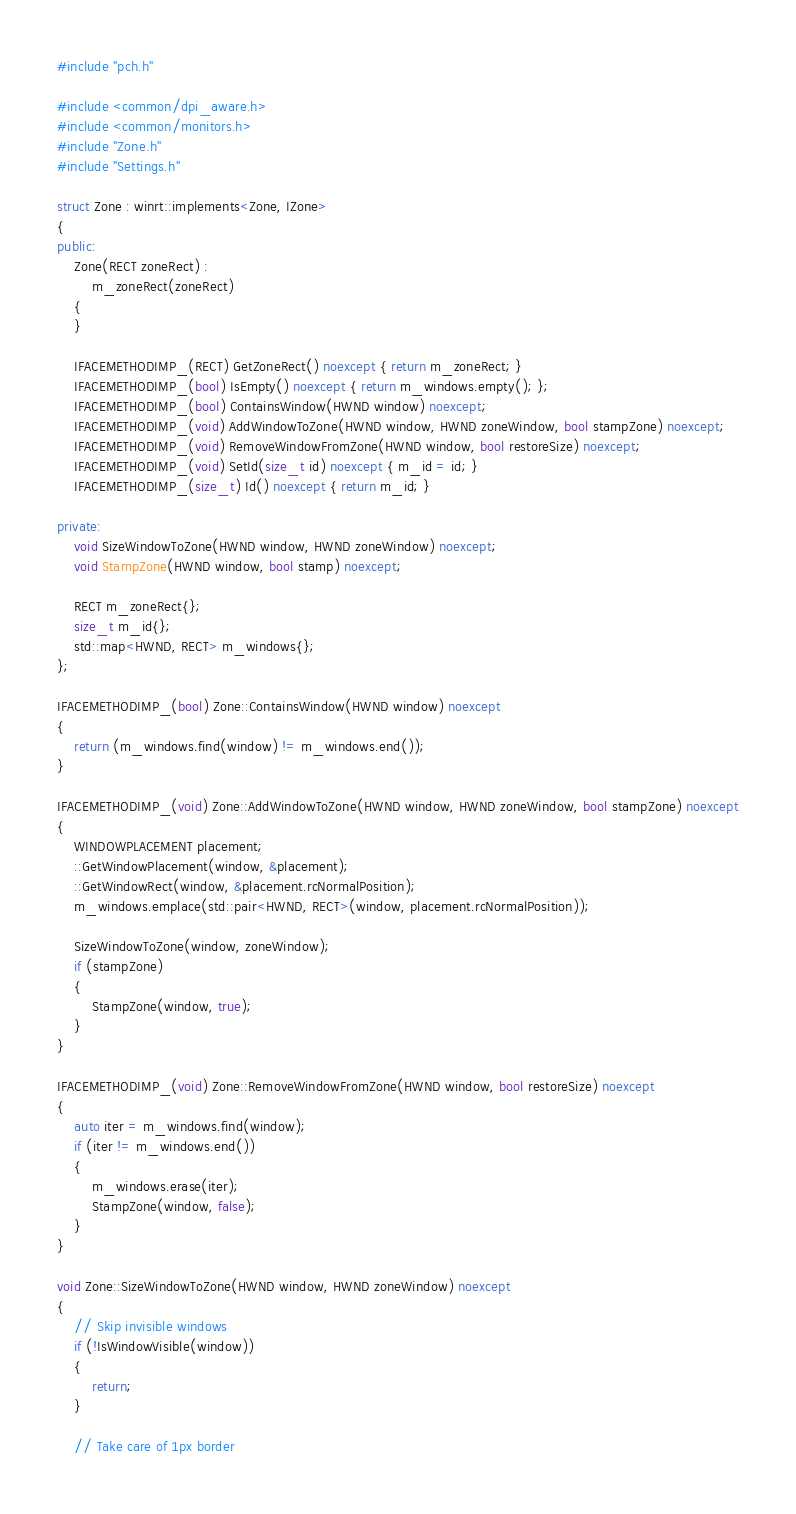<code> <loc_0><loc_0><loc_500><loc_500><_C++_>#include "pch.h"

#include <common/dpi_aware.h>
#include <common/monitors.h>
#include "Zone.h"
#include "Settings.h"

struct Zone : winrt::implements<Zone, IZone>
{
public:
    Zone(RECT zoneRect) :
        m_zoneRect(zoneRect)
    {
    }

    IFACEMETHODIMP_(RECT) GetZoneRect() noexcept { return m_zoneRect; }
    IFACEMETHODIMP_(bool) IsEmpty() noexcept { return m_windows.empty(); };
    IFACEMETHODIMP_(bool) ContainsWindow(HWND window) noexcept;
    IFACEMETHODIMP_(void) AddWindowToZone(HWND window, HWND zoneWindow, bool stampZone) noexcept;
    IFACEMETHODIMP_(void) RemoveWindowFromZone(HWND window, bool restoreSize) noexcept;
    IFACEMETHODIMP_(void) SetId(size_t id) noexcept { m_id = id; }
    IFACEMETHODIMP_(size_t) Id() noexcept { return m_id; }

private:
    void SizeWindowToZone(HWND window, HWND zoneWindow) noexcept;
    void StampZone(HWND window, bool stamp) noexcept;

    RECT m_zoneRect{};
    size_t m_id{};
    std::map<HWND, RECT> m_windows{};
};

IFACEMETHODIMP_(bool) Zone::ContainsWindow(HWND window) noexcept
{
    return (m_windows.find(window) != m_windows.end());
}

IFACEMETHODIMP_(void) Zone::AddWindowToZone(HWND window, HWND zoneWindow, bool stampZone) noexcept
{
    WINDOWPLACEMENT placement;
    ::GetWindowPlacement(window, &placement);
    ::GetWindowRect(window, &placement.rcNormalPosition);
    m_windows.emplace(std::pair<HWND, RECT>(window, placement.rcNormalPosition));

    SizeWindowToZone(window, zoneWindow);
    if (stampZone)
    {
        StampZone(window, true);
    }
}

IFACEMETHODIMP_(void) Zone::RemoveWindowFromZone(HWND window, bool restoreSize) noexcept
{
    auto iter = m_windows.find(window);
    if (iter != m_windows.end())
    {
        m_windows.erase(iter);
        StampZone(window, false);
    }
}

void Zone::SizeWindowToZone(HWND window, HWND zoneWindow) noexcept
{
    // Skip invisible windows
    if (!IsWindowVisible(window))
    {
        return;
    }
  
    // Take care of 1px border</code> 